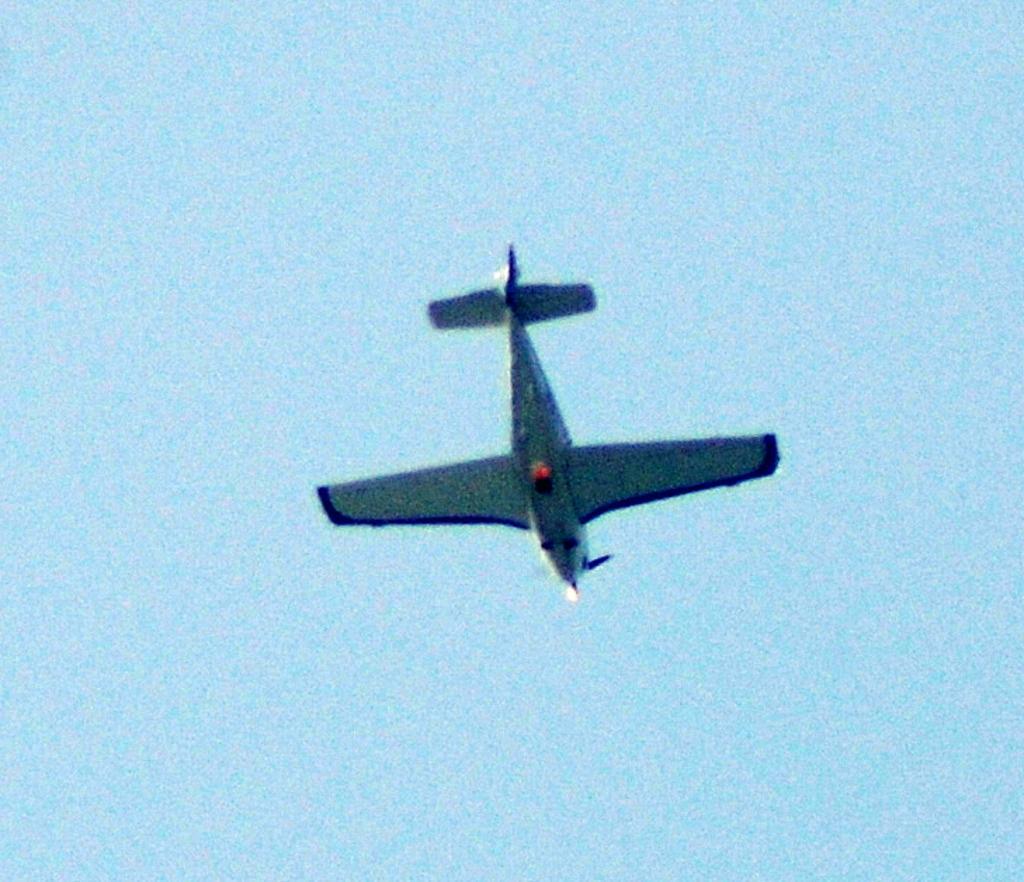Describe this image in one or two sentences. In this image I can see an airplane flying in the air. It is in navy blue color. In the back I can see the blue sky. 